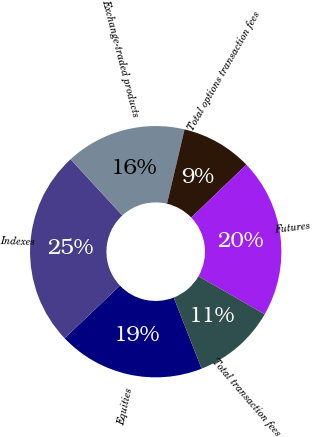Convert chart to OTSL. <chart><loc_0><loc_0><loc_500><loc_500><pie_chart><fcel>Equities<fcel>Indexes<fcel>Exchange-traded products<fcel>Total options transaction fees<fcel>Futures<fcel>Total transaction fees<nl><fcel>18.86%<fcel>25.25%<fcel>15.53%<fcel>9.14%<fcel>20.47%<fcel>10.75%<nl></chart> 